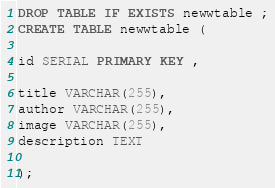Convert code to text. <code><loc_0><loc_0><loc_500><loc_500><_SQL_>DROP TABLE IF EXISTS newwtable ;
CREATE TABLE newwtable (

id SERIAL PRIMARY KEY ,

title VARCHAR(255),
author VARCHAR(255),
image VARCHAR(255),
description TEXT 

);</code> 